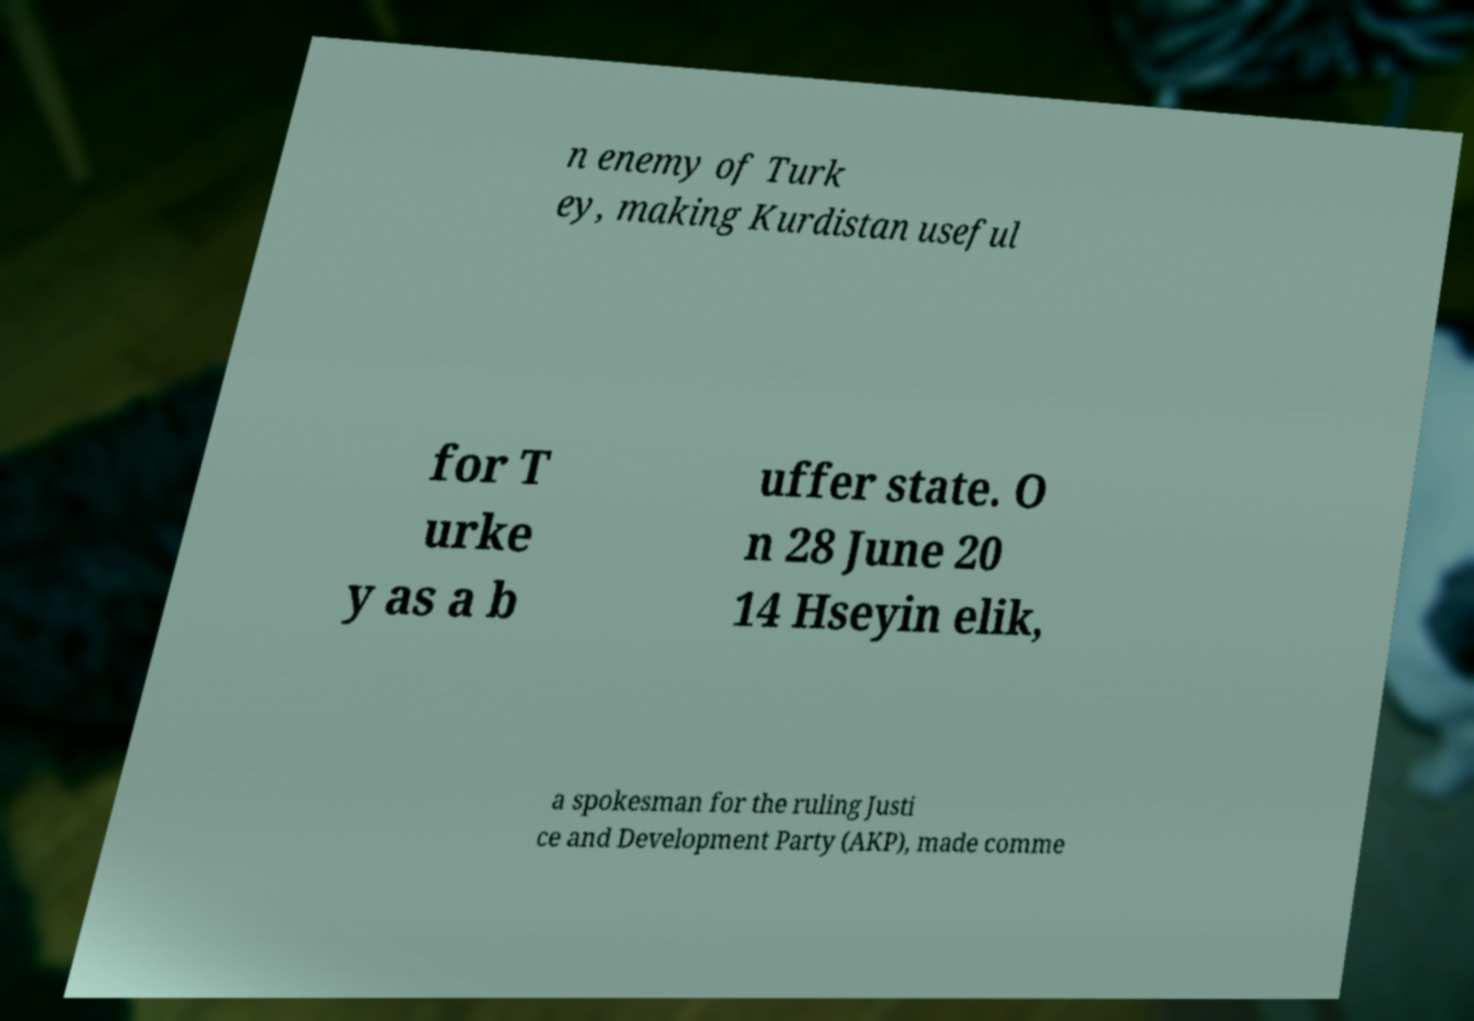Can you read and provide the text displayed in the image?This photo seems to have some interesting text. Can you extract and type it out for me? n enemy of Turk ey, making Kurdistan useful for T urke y as a b uffer state. O n 28 June 20 14 Hseyin elik, a spokesman for the ruling Justi ce and Development Party (AKP), made comme 